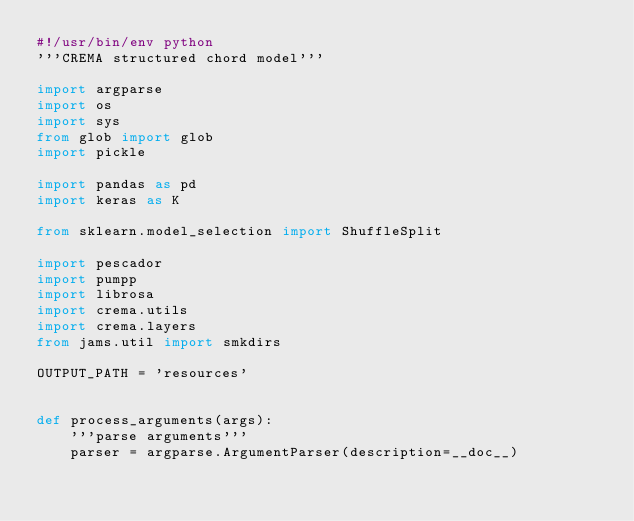Convert code to text. <code><loc_0><loc_0><loc_500><loc_500><_Python_>#!/usr/bin/env python
'''CREMA structured chord model'''

import argparse
import os
import sys
from glob import glob
import pickle

import pandas as pd
import keras as K

from sklearn.model_selection import ShuffleSplit

import pescador
import pumpp
import librosa
import crema.utils
import crema.layers
from jams.util import smkdirs

OUTPUT_PATH = 'resources'


def process_arguments(args):
    '''parse arguments'''
    parser = argparse.ArgumentParser(description=__doc__)
</code> 